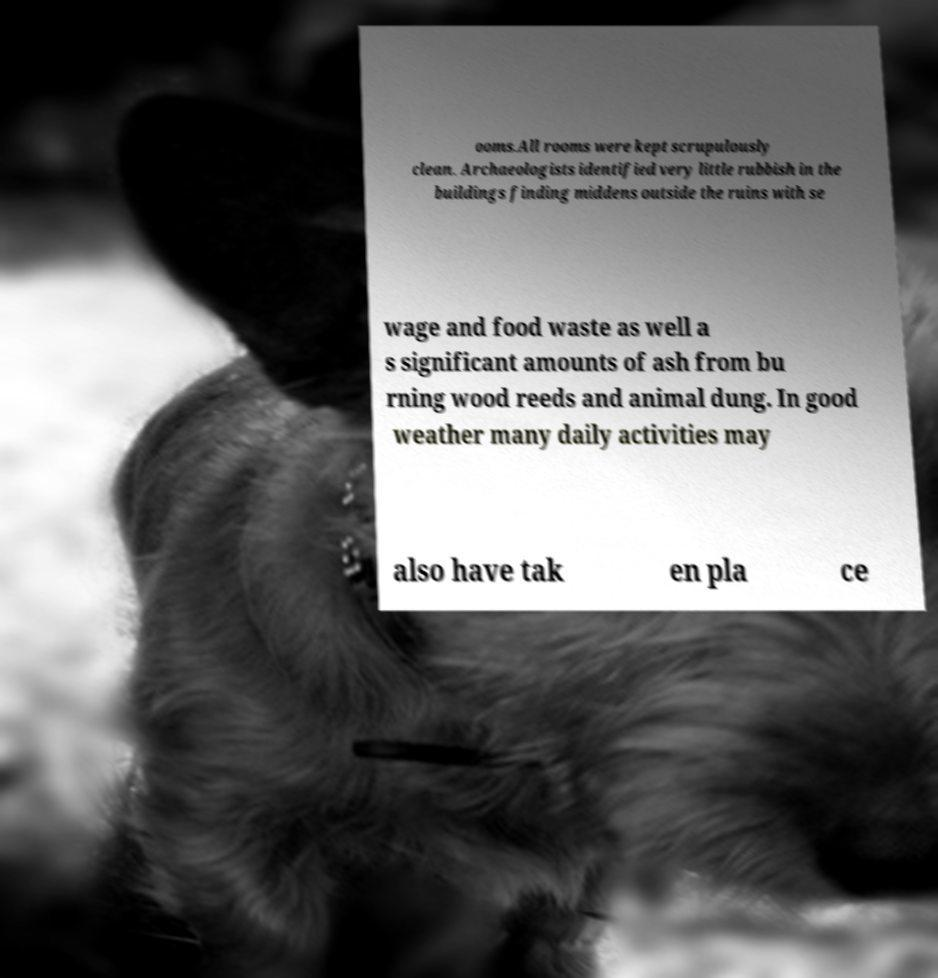What messages or text are displayed in this image? I need them in a readable, typed format. ooms.All rooms were kept scrupulously clean. Archaeologists identified very little rubbish in the buildings finding middens outside the ruins with se wage and food waste as well a s significant amounts of ash from bu rning wood reeds and animal dung. In good weather many daily activities may also have tak en pla ce 